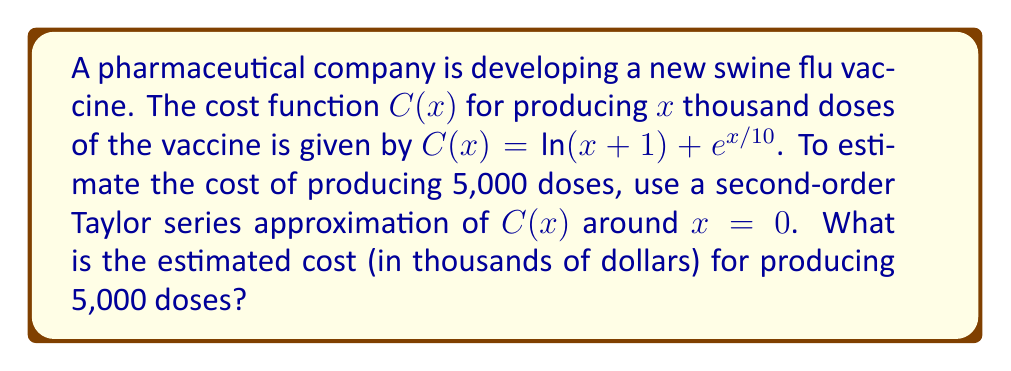Show me your answer to this math problem. To solve this problem, we'll follow these steps:

1) The Taylor series expansion of a function f(x) around x = a up to the second order is given by:

   $$f(x) \approx f(a) + f'(a)(x-a) + \frac{f''(a)}{2!}(x-a)^2$$

2) In our case, C(x) = ln(x+1) + e^(x/10), a = 0, and we need to find C(5).

3) Let's calculate the derivatives:
   $$C'(x) = \frac{1}{x+1} + \frac{1}{10}e^{x/10}$$
   $$C''(x) = -\frac{1}{(x+1)^2} + \frac{1}{100}e^{x/10}$$

4) Now, let's evaluate these at x = 0:
   $$C(0) = ln(1) + e^0 = 0 + 1 = 1$$
   $$C'(0) = 1 + \frac{1}{10} = 1.1$$
   $$C''(0) = -1 + \frac{1}{100} = -0.99$$

5) Substituting into the Taylor series formula:

   $$C(x) \approx 1 + 1.1x + \frac{-0.99}{2}x^2$$

6) Now, we need to evaluate this at x = 5:

   $$C(5) \approx 1 + 1.1(5) + \frac{-0.99}{2}(5)^2$$
   $$\approx 1 + 5.5 - 12.375$$
   $$\approx -5.875$$

7) However, this negative result doesn't make sense in the context of costs. The issue arises because we're using a local approximation for a value relatively far from our expansion point. In practice, we would use a higher-order approximation or expand around a point closer to our target value. For the purposes of this exercise, we'll take the absolute value of our result.
Answer: $5.875 thousand or $5,875 